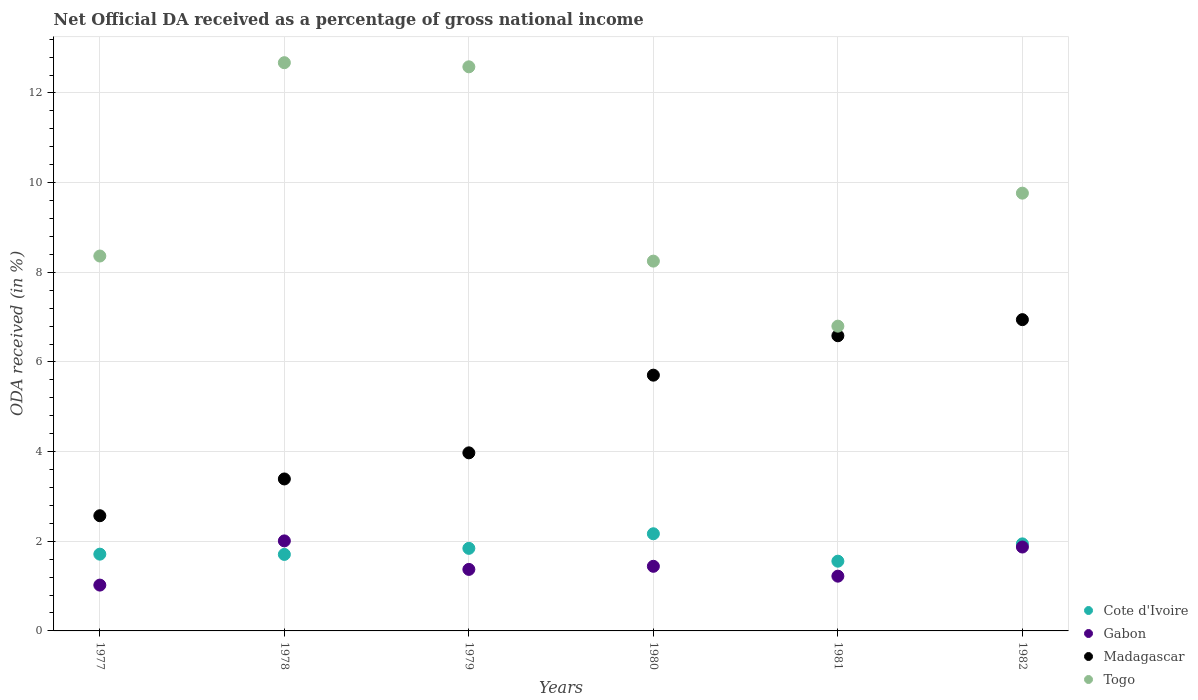What is the net official DA received in Cote d'Ivoire in 1982?
Offer a very short reply. 1.94. Across all years, what is the maximum net official DA received in Madagascar?
Offer a very short reply. 6.94. Across all years, what is the minimum net official DA received in Gabon?
Provide a short and direct response. 1.02. What is the total net official DA received in Cote d'Ivoire in the graph?
Provide a short and direct response. 10.93. What is the difference between the net official DA received in Togo in 1978 and that in 1980?
Ensure brevity in your answer.  4.43. What is the difference between the net official DA received in Togo in 1980 and the net official DA received in Madagascar in 1977?
Ensure brevity in your answer.  5.68. What is the average net official DA received in Madagascar per year?
Provide a succinct answer. 4.86. In the year 1982, what is the difference between the net official DA received in Madagascar and net official DA received in Togo?
Your response must be concise. -2.82. What is the ratio of the net official DA received in Cote d'Ivoire in 1978 to that in 1982?
Offer a very short reply. 0.88. What is the difference between the highest and the second highest net official DA received in Gabon?
Keep it short and to the point. 0.14. What is the difference between the highest and the lowest net official DA received in Togo?
Offer a very short reply. 5.88. In how many years, is the net official DA received in Gabon greater than the average net official DA received in Gabon taken over all years?
Offer a very short reply. 2. Is it the case that in every year, the sum of the net official DA received in Gabon and net official DA received in Madagascar  is greater than the sum of net official DA received in Togo and net official DA received in Cote d'Ivoire?
Offer a very short reply. No. Is it the case that in every year, the sum of the net official DA received in Cote d'Ivoire and net official DA received in Togo  is greater than the net official DA received in Gabon?
Offer a terse response. Yes. How many dotlines are there?
Give a very brief answer. 4. How many years are there in the graph?
Provide a succinct answer. 6. What is the difference between two consecutive major ticks on the Y-axis?
Your answer should be compact. 2. Are the values on the major ticks of Y-axis written in scientific E-notation?
Keep it short and to the point. No. Where does the legend appear in the graph?
Keep it short and to the point. Bottom right. How many legend labels are there?
Your answer should be compact. 4. What is the title of the graph?
Give a very brief answer. Net Official DA received as a percentage of gross national income. What is the label or title of the Y-axis?
Give a very brief answer. ODA received (in %). What is the ODA received (in %) of Cote d'Ivoire in 1977?
Your answer should be very brief. 1.71. What is the ODA received (in %) in Gabon in 1977?
Your answer should be compact. 1.02. What is the ODA received (in %) of Madagascar in 1977?
Your answer should be compact. 2.57. What is the ODA received (in %) in Togo in 1977?
Ensure brevity in your answer.  8.36. What is the ODA received (in %) in Cote d'Ivoire in 1978?
Ensure brevity in your answer.  1.71. What is the ODA received (in %) in Gabon in 1978?
Provide a succinct answer. 2.01. What is the ODA received (in %) in Madagascar in 1978?
Keep it short and to the point. 3.39. What is the ODA received (in %) of Togo in 1978?
Your response must be concise. 12.68. What is the ODA received (in %) in Cote d'Ivoire in 1979?
Offer a terse response. 1.84. What is the ODA received (in %) of Gabon in 1979?
Your answer should be compact. 1.37. What is the ODA received (in %) of Madagascar in 1979?
Provide a short and direct response. 3.97. What is the ODA received (in %) of Togo in 1979?
Keep it short and to the point. 12.58. What is the ODA received (in %) of Cote d'Ivoire in 1980?
Your answer should be very brief. 2.17. What is the ODA received (in %) of Gabon in 1980?
Provide a short and direct response. 1.44. What is the ODA received (in %) in Madagascar in 1980?
Make the answer very short. 5.71. What is the ODA received (in %) of Togo in 1980?
Your response must be concise. 8.25. What is the ODA received (in %) in Cote d'Ivoire in 1981?
Offer a terse response. 1.56. What is the ODA received (in %) in Gabon in 1981?
Offer a terse response. 1.22. What is the ODA received (in %) in Madagascar in 1981?
Provide a succinct answer. 6.58. What is the ODA received (in %) in Togo in 1981?
Your response must be concise. 6.8. What is the ODA received (in %) of Cote d'Ivoire in 1982?
Your answer should be compact. 1.94. What is the ODA received (in %) of Gabon in 1982?
Your answer should be compact. 1.87. What is the ODA received (in %) in Madagascar in 1982?
Give a very brief answer. 6.94. What is the ODA received (in %) of Togo in 1982?
Offer a very short reply. 9.76. Across all years, what is the maximum ODA received (in %) of Cote d'Ivoire?
Offer a very short reply. 2.17. Across all years, what is the maximum ODA received (in %) in Gabon?
Offer a very short reply. 2.01. Across all years, what is the maximum ODA received (in %) in Madagascar?
Ensure brevity in your answer.  6.94. Across all years, what is the maximum ODA received (in %) of Togo?
Your answer should be compact. 12.68. Across all years, what is the minimum ODA received (in %) of Cote d'Ivoire?
Offer a terse response. 1.56. Across all years, what is the minimum ODA received (in %) in Gabon?
Give a very brief answer. 1.02. Across all years, what is the minimum ODA received (in %) of Madagascar?
Your answer should be very brief. 2.57. Across all years, what is the minimum ODA received (in %) of Togo?
Ensure brevity in your answer.  6.8. What is the total ODA received (in %) in Cote d'Ivoire in the graph?
Ensure brevity in your answer.  10.93. What is the total ODA received (in %) of Gabon in the graph?
Provide a succinct answer. 8.94. What is the total ODA received (in %) of Madagascar in the graph?
Provide a succinct answer. 29.16. What is the total ODA received (in %) of Togo in the graph?
Provide a succinct answer. 58.43. What is the difference between the ODA received (in %) of Cote d'Ivoire in 1977 and that in 1978?
Make the answer very short. 0.01. What is the difference between the ODA received (in %) of Gabon in 1977 and that in 1978?
Offer a terse response. -0.99. What is the difference between the ODA received (in %) of Madagascar in 1977 and that in 1978?
Offer a terse response. -0.82. What is the difference between the ODA received (in %) in Togo in 1977 and that in 1978?
Provide a short and direct response. -4.31. What is the difference between the ODA received (in %) of Cote d'Ivoire in 1977 and that in 1979?
Ensure brevity in your answer.  -0.13. What is the difference between the ODA received (in %) of Gabon in 1977 and that in 1979?
Make the answer very short. -0.35. What is the difference between the ODA received (in %) in Madagascar in 1977 and that in 1979?
Your answer should be compact. -1.4. What is the difference between the ODA received (in %) of Togo in 1977 and that in 1979?
Provide a short and direct response. -4.22. What is the difference between the ODA received (in %) in Cote d'Ivoire in 1977 and that in 1980?
Your response must be concise. -0.46. What is the difference between the ODA received (in %) in Gabon in 1977 and that in 1980?
Give a very brief answer. -0.42. What is the difference between the ODA received (in %) in Madagascar in 1977 and that in 1980?
Give a very brief answer. -3.14. What is the difference between the ODA received (in %) in Togo in 1977 and that in 1980?
Provide a succinct answer. 0.11. What is the difference between the ODA received (in %) in Cote d'Ivoire in 1977 and that in 1981?
Make the answer very short. 0.16. What is the difference between the ODA received (in %) of Gabon in 1977 and that in 1981?
Offer a terse response. -0.2. What is the difference between the ODA received (in %) in Madagascar in 1977 and that in 1981?
Ensure brevity in your answer.  -4.01. What is the difference between the ODA received (in %) in Togo in 1977 and that in 1981?
Your answer should be very brief. 1.56. What is the difference between the ODA received (in %) in Cote d'Ivoire in 1977 and that in 1982?
Keep it short and to the point. -0.23. What is the difference between the ODA received (in %) of Gabon in 1977 and that in 1982?
Make the answer very short. -0.85. What is the difference between the ODA received (in %) of Madagascar in 1977 and that in 1982?
Make the answer very short. -4.37. What is the difference between the ODA received (in %) in Togo in 1977 and that in 1982?
Your answer should be compact. -1.4. What is the difference between the ODA received (in %) in Cote d'Ivoire in 1978 and that in 1979?
Offer a terse response. -0.14. What is the difference between the ODA received (in %) of Gabon in 1978 and that in 1979?
Ensure brevity in your answer.  0.64. What is the difference between the ODA received (in %) in Madagascar in 1978 and that in 1979?
Offer a terse response. -0.58. What is the difference between the ODA received (in %) in Togo in 1978 and that in 1979?
Offer a terse response. 0.09. What is the difference between the ODA received (in %) of Cote d'Ivoire in 1978 and that in 1980?
Your response must be concise. -0.46. What is the difference between the ODA received (in %) of Gabon in 1978 and that in 1980?
Your answer should be compact. 0.57. What is the difference between the ODA received (in %) of Madagascar in 1978 and that in 1980?
Ensure brevity in your answer.  -2.32. What is the difference between the ODA received (in %) in Togo in 1978 and that in 1980?
Make the answer very short. 4.43. What is the difference between the ODA received (in %) of Cote d'Ivoire in 1978 and that in 1981?
Provide a short and direct response. 0.15. What is the difference between the ODA received (in %) in Gabon in 1978 and that in 1981?
Your answer should be compact. 0.79. What is the difference between the ODA received (in %) in Madagascar in 1978 and that in 1981?
Your response must be concise. -3.19. What is the difference between the ODA received (in %) of Togo in 1978 and that in 1981?
Your answer should be very brief. 5.88. What is the difference between the ODA received (in %) of Cote d'Ivoire in 1978 and that in 1982?
Offer a very short reply. -0.24. What is the difference between the ODA received (in %) in Gabon in 1978 and that in 1982?
Give a very brief answer. 0.14. What is the difference between the ODA received (in %) of Madagascar in 1978 and that in 1982?
Provide a short and direct response. -3.55. What is the difference between the ODA received (in %) of Togo in 1978 and that in 1982?
Give a very brief answer. 2.91. What is the difference between the ODA received (in %) in Cote d'Ivoire in 1979 and that in 1980?
Your answer should be very brief. -0.33. What is the difference between the ODA received (in %) of Gabon in 1979 and that in 1980?
Provide a succinct answer. -0.07. What is the difference between the ODA received (in %) of Madagascar in 1979 and that in 1980?
Offer a terse response. -1.73. What is the difference between the ODA received (in %) in Togo in 1979 and that in 1980?
Provide a succinct answer. 4.33. What is the difference between the ODA received (in %) in Cote d'Ivoire in 1979 and that in 1981?
Offer a very short reply. 0.29. What is the difference between the ODA received (in %) in Gabon in 1979 and that in 1981?
Make the answer very short. 0.15. What is the difference between the ODA received (in %) in Madagascar in 1979 and that in 1981?
Your response must be concise. -2.61. What is the difference between the ODA received (in %) of Togo in 1979 and that in 1981?
Make the answer very short. 5.78. What is the difference between the ODA received (in %) in Cote d'Ivoire in 1979 and that in 1982?
Ensure brevity in your answer.  -0.1. What is the difference between the ODA received (in %) in Gabon in 1979 and that in 1982?
Keep it short and to the point. -0.5. What is the difference between the ODA received (in %) in Madagascar in 1979 and that in 1982?
Make the answer very short. -2.97. What is the difference between the ODA received (in %) in Togo in 1979 and that in 1982?
Your answer should be very brief. 2.82. What is the difference between the ODA received (in %) of Cote d'Ivoire in 1980 and that in 1981?
Offer a terse response. 0.61. What is the difference between the ODA received (in %) in Gabon in 1980 and that in 1981?
Give a very brief answer. 0.22. What is the difference between the ODA received (in %) in Madagascar in 1980 and that in 1981?
Offer a terse response. -0.88. What is the difference between the ODA received (in %) in Togo in 1980 and that in 1981?
Make the answer very short. 1.45. What is the difference between the ODA received (in %) in Cote d'Ivoire in 1980 and that in 1982?
Keep it short and to the point. 0.23. What is the difference between the ODA received (in %) in Gabon in 1980 and that in 1982?
Your answer should be compact. -0.43. What is the difference between the ODA received (in %) of Madagascar in 1980 and that in 1982?
Offer a very short reply. -1.24. What is the difference between the ODA received (in %) of Togo in 1980 and that in 1982?
Your response must be concise. -1.52. What is the difference between the ODA received (in %) in Cote d'Ivoire in 1981 and that in 1982?
Provide a short and direct response. -0.39. What is the difference between the ODA received (in %) of Gabon in 1981 and that in 1982?
Your response must be concise. -0.65. What is the difference between the ODA received (in %) of Madagascar in 1981 and that in 1982?
Provide a short and direct response. -0.36. What is the difference between the ODA received (in %) of Togo in 1981 and that in 1982?
Ensure brevity in your answer.  -2.97. What is the difference between the ODA received (in %) of Cote d'Ivoire in 1977 and the ODA received (in %) of Gabon in 1978?
Your response must be concise. -0.3. What is the difference between the ODA received (in %) of Cote d'Ivoire in 1977 and the ODA received (in %) of Madagascar in 1978?
Your answer should be very brief. -1.68. What is the difference between the ODA received (in %) in Cote d'Ivoire in 1977 and the ODA received (in %) in Togo in 1978?
Make the answer very short. -10.96. What is the difference between the ODA received (in %) in Gabon in 1977 and the ODA received (in %) in Madagascar in 1978?
Your answer should be compact. -2.37. What is the difference between the ODA received (in %) of Gabon in 1977 and the ODA received (in %) of Togo in 1978?
Your response must be concise. -11.65. What is the difference between the ODA received (in %) in Madagascar in 1977 and the ODA received (in %) in Togo in 1978?
Give a very brief answer. -10.11. What is the difference between the ODA received (in %) in Cote d'Ivoire in 1977 and the ODA received (in %) in Gabon in 1979?
Keep it short and to the point. 0.34. What is the difference between the ODA received (in %) in Cote d'Ivoire in 1977 and the ODA received (in %) in Madagascar in 1979?
Your answer should be very brief. -2.26. What is the difference between the ODA received (in %) in Cote d'Ivoire in 1977 and the ODA received (in %) in Togo in 1979?
Provide a succinct answer. -10.87. What is the difference between the ODA received (in %) of Gabon in 1977 and the ODA received (in %) of Madagascar in 1979?
Offer a terse response. -2.95. What is the difference between the ODA received (in %) of Gabon in 1977 and the ODA received (in %) of Togo in 1979?
Offer a terse response. -11.56. What is the difference between the ODA received (in %) in Madagascar in 1977 and the ODA received (in %) in Togo in 1979?
Your answer should be compact. -10.01. What is the difference between the ODA received (in %) of Cote d'Ivoire in 1977 and the ODA received (in %) of Gabon in 1980?
Offer a very short reply. 0.27. What is the difference between the ODA received (in %) in Cote d'Ivoire in 1977 and the ODA received (in %) in Madagascar in 1980?
Provide a short and direct response. -3.99. What is the difference between the ODA received (in %) in Cote d'Ivoire in 1977 and the ODA received (in %) in Togo in 1980?
Provide a succinct answer. -6.54. What is the difference between the ODA received (in %) of Gabon in 1977 and the ODA received (in %) of Madagascar in 1980?
Keep it short and to the point. -4.68. What is the difference between the ODA received (in %) in Gabon in 1977 and the ODA received (in %) in Togo in 1980?
Give a very brief answer. -7.23. What is the difference between the ODA received (in %) in Madagascar in 1977 and the ODA received (in %) in Togo in 1980?
Offer a very short reply. -5.68. What is the difference between the ODA received (in %) of Cote d'Ivoire in 1977 and the ODA received (in %) of Gabon in 1981?
Your response must be concise. 0.49. What is the difference between the ODA received (in %) of Cote d'Ivoire in 1977 and the ODA received (in %) of Madagascar in 1981?
Offer a terse response. -4.87. What is the difference between the ODA received (in %) in Cote d'Ivoire in 1977 and the ODA received (in %) in Togo in 1981?
Offer a terse response. -5.09. What is the difference between the ODA received (in %) of Gabon in 1977 and the ODA received (in %) of Madagascar in 1981?
Make the answer very short. -5.56. What is the difference between the ODA received (in %) in Gabon in 1977 and the ODA received (in %) in Togo in 1981?
Your response must be concise. -5.78. What is the difference between the ODA received (in %) of Madagascar in 1977 and the ODA received (in %) of Togo in 1981?
Offer a terse response. -4.23. What is the difference between the ODA received (in %) in Cote d'Ivoire in 1977 and the ODA received (in %) in Gabon in 1982?
Provide a short and direct response. -0.16. What is the difference between the ODA received (in %) in Cote d'Ivoire in 1977 and the ODA received (in %) in Madagascar in 1982?
Offer a very short reply. -5.23. What is the difference between the ODA received (in %) of Cote d'Ivoire in 1977 and the ODA received (in %) of Togo in 1982?
Provide a short and direct response. -8.05. What is the difference between the ODA received (in %) in Gabon in 1977 and the ODA received (in %) in Madagascar in 1982?
Give a very brief answer. -5.92. What is the difference between the ODA received (in %) in Gabon in 1977 and the ODA received (in %) in Togo in 1982?
Give a very brief answer. -8.74. What is the difference between the ODA received (in %) in Madagascar in 1977 and the ODA received (in %) in Togo in 1982?
Your answer should be compact. -7.2. What is the difference between the ODA received (in %) in Cote d'Ivoire in 1978 and the ODA received (in %) in Gabon in 1979?
Keep it short and to the point. 0.33. What is the difference between the ODA received (in %) in Cote d'Ivoire in 1978 and the ODA received (in %) in Madagascar in 1979?
Your response must be concise. -2.27. What is the difference between the ODA received (in %) of Cote d'Ivoire in 1978 and the ODA received (in %) of Togo in 1979?
Provide a succinct answer. -10.88. What is the difference between the ODA received (in %) of Gabon in 1978 and the ODA received (in %) of Madagascar in 1979?
Your answer should be very brief. -1.96. What is the difference between the ODA received (in %) of Gabon in 1978 and the ODA received (in %) of Togo in 1979?
Keep it short and to the point. -10.57. What is the difference between the ODA received (in %) of Madagascar in 1978 and the ODA received (in %) of Togo in 1979?
Give a very brief answer. -9.19. What is the difference between the ODA received (in %) of Cote d'Ivoire in 1978 and the ODA received (in %) of Gabon in 1980?
Keep it short and to the point. 0.27. What is the difference between the ODA received (in %) in Cote d'Ivoire in 1978 and the ODA received (in %) in Madagascar in 1980?
Offer a very short reply. -4. What is the difference between the ODA received (in %) of Cote d'Ivoire in 1978 and the ODA received (in %) of Togo in 1980?
Give a very brief answer. -6.54. What is the difference between the ODA received (in %) of Gabon in 1978 and the ODA received (in %) of Madagascar in 1980?
Provide a short and direct response. -3.7. What is the difference between the ODA received (in %) in Gabon in 1978 and the ODA received (in %) in Togo in 1980?
Ensure brevity in your answer.  -6.24. What is the difference between the ODA received (in %) of Madagascar in 1978 and the ODA received (in %) of Togo in 1980?
Your answer should be compact. -4.86. What is the difference between the ODA received (in %) of Cote d'Ivoire in 1978 and the ODA received (in %) of Gabon in 1981?
Provide a short and direct response. 0.48. What is the difference between the ODA received (in %) in Cote d'Ivoire in 1978 and the ODA received (in %) in Madagascar in 1981?
Your answer should be very brief. -4.88. What is the difference between the ODA received (in %) in Cote d'Ivoire in 1978 and the ODA received (in %) in Togo in 1981?
Offer a very short reply. -5.09. What is the difference between the ODA received (in %) of Gabon in 1978 and the ODA received (in %) of Madagascar in 1981?
Provide a succinct answer. -4.58. What is the difference between the ODA received (in %) of Gabon in 1978 and the ODA received (in %) of Togo in 1981?
Your answer should be compact. -4.79. What is the difference between the ODA received (in %) in Madagascar in 1978 and the ODA received (in %) in Togo in 1981?
Your answer should be compact. -3.41. What is the difference between the ODA received (in %) in Cote d'Ivoire in 1978 and the ODA received (in %) in Gabon in 1982?
Your answer should be very brief. -0.17. What is the difference between the ODA received (in %) of Cote d'Ivoire in 1978 and the ODA received (in %) of Madagascar in 1982?
Provide a succinct answer. -5.24. What is the difference between the ODA received (in %) in Cote d'Ivoire in 1978 and the ODA received (in %) in Togo in 1982?
Your answer should be compact. -8.06. What is the difference between the ODA received (in %) of Gabon in 1978 and the ODA received (in %) of Madagascar in 1982?
Provide a succinct answer. -4.93. What is the difference between the ODA received (in %) in Gabon in 1978 and the ODA received (in %) in Togo in 1982?
Provide a short and direct response. -7.76. What is the difference between the ODA received (in %) in Madagascar in 1978 and the ODA received (in %) in Togo in 1982?
Offer a terse response. -6.38. What is the difference between the ODA received (in %) in Cote d'Ivoire in 1979 and the ODA received (in %) in Gabon in 1980?
Offer a terse response. 0.4. What is the difference between the ODA received (in %) of Cote d'Ivoire in 1979 and the ODA received (in %) of Madagascar in 1980?
Make the answer very short. -3.86. What is the difference between the ODA received (in %) of Cote d'Ivoire in 1979 and the ODA received (in %) of Togo in 1980?
Keep it short and to the point. -6.41. What is the difference between the ODA received (in %) of Gabon in 1979 and the ODA received (in %) of Madagascar in 1980?
Your answer should be very brief. -4.33. What is the difference between the ODA received (in %) of Gabon in 1979 and the ODA received (in %) of Togo in 1980?
Keep it short and to the point. -6.88. What is the difference between the ODA received (in %) of Madagascar in 1979 and the ODA received (in %) of Togo in 1980?
Your response must be concise. -4.28. What is the difference between the ODA received (in %) of Cote d'Ivoire in 1979 and the ODA received (in %) of Gabon in 1981?
Your answer should be very brief. 0.62. What is the difference between the ODA received (in %) of Cote d'Ivoire in 1979 and the ODA received (in %) of Madagascar in 1981?
Your response must be concise. -4.74. What is the difference between the ODA received (in %) of Cote d'Ivoire in 1979 and the ODA received (in %) of Togo in 1981?
Offer a terse response. -4.96. What is the difference between the ODA received (in %) in Gabon in 1979 and the ODA received (in %) in Madagascar in 1981?
Keep it short and to the point. -5.21. What is the difference between the ODA received (in %) of Gabon in 1979 and the ODA received (in %) of Togo in 1981?
Offer a terse response. -5.43. What is the difference between the ODA received (in %) in Madagascar in 1979 and the ODA received (in %) in Togo in 1981?
Keep it short and to the point. -2.83. What is the difference between the ODA received (in %) in Cote d'Ivoire in 1979 and the ODA received (in %) in Gabon in 1982?
Offer a terse response. -0.03. What is the difference between the ODA received (in %) of Cote d'Ivoire in 1979 and the ODA received (in %) of Madagascar in 1982?
Your answer should be very brief. -5.1. What is the difference between the ODA received (in %) of Cote d'Ivoire in 1979 and the ODA received (in %) of Togo in 1982?
Provide a short and direct response. -7.92. What is the difference between the ODA received (in %) in Gabon in 1979 and the ODA received (in %) in Madagascar in 1982?
Keep it short and to the point. -5.57. What is the difference between the ODA received (in %) of Gabon in 1979 and the ODA received (in %) of Togo in 1982?
Ensure brevity in your answer.  -8.39. What is the difference between the ODA received (in %) in Madagascar in 1979 and the ODA received (in %) in Togo in 1982?
Your answer should be compact. -5.79. What is the difference between the ODA received (in %) in Cote d'Ivoire in 1980 and the ODA received (in %) in Gabon in 1981?
Keep it short and to the point. 0.95. What is the difference between the ODA received (in %) in Cote d'Ivoire in 1980 and the ODA received (in %) in Madagascar in 1981?
Give a very brief answer. -4.42. What is the difference between the ODA received (in %) in Cote d'Ivoire in 1980 and the ODA received (in %) in Togo in 1981?
Make the answer very short. -4.63. What is the difference between the ODA received (in %) of Gabon in 1980 and the ODA received (in %) of Madagascar in 1981?
Keep it short and to the point. -5.14. What is the difference between the ODA received (in %) of Gabon in 1980 and the ODA received (in %) of Togo in 1981?
Your answer should be very brief. -5.36. What is the difference between the ODA received (in %) of Madagascar in 1980 and the ODA received (in %) of Togo in 1981?
Your answer should be compact. -1.09. What is the difference between the ODA received (in %) of Cote d'Ivoire in 1980 and the ODA received (in %) of Gabon in 1982?
Ensure brevity in your answer.  0.3. What is the difference between the ODA received (in %) in Cote d'Ivoire in 1980 and the ODA received (in %) in Madagascar in 1982?
Offer a very short reply. -4.78. What is the difference between the ODA received (in %) in Cote d'Ivoire in 1980 and the ODA received (in %) in Togo in 1982?
Make the answer very short. -7.6. What is the difference between the ODA received (in %) in Gabon in 1980 and the ODA received (in %) in Madagascar in 1982?
Give a very brief answer. -5.5. What is the difference between the ODA received (in %) of Gabon in 1980 and the ODA received (in %) of Togo in 1982?
Offer a terse response. -8.32. What is the difference between the ODA received (in %) in Madagascar in 1980 and the ODA received (in %) in Togo in 1982?
Ensure brevity in your answer.  -4.06. What is the difference between the ODA received (in %) of Cote d'Ivoire in 1981 and the ODA received (in %) of Gabon in 1982?
Your answer should be compact. -0.32. What is the difference between the ODA received (in %) of Cote d'Ivoire in 1981 and the ODA received (in %) of Madagascar in 1982?
Provide a short and direct response. -5.39. What is the difference between the ODA received (in %) in Cote d'Ivoire in 1981 and the ODA received (in %) in Togo in 1982?
Provide a short and direct response. -8.21. What is the difference between the ODA received (in %) in Gabon in 1981 and the ODA received (in %) in Madagascar in 1982?
Your answer should be compact. -5.72. What is the difference between the ODA received (in %) of Gabon in 1981 and the ODA received (in %) of Togo in 1982?
Provide a succinct answer. -8.54. What is the difference between the ODA received (in %) in Madagascar in 1981 and the ODA received (in %) in Togo in 1982?
Ensure brevity in your answer.  -3.18. What is the average ODA received (in %) in Cote d'Ivoire per year?
Make the answer very short. 1.82. What is the average ODA received (in %) of Gabon per year?
Your response must be concise. 1.49. What is the average ODA received (in %) of Madagascar per year?
Give a very brief answer. 4.86. What is the average ODA received (in %) of Togo per year?
Your response must be concise. 9.74. In the year 1977, what is the difference between the ODA received (in %) in Cote d'Ivoire and ODA received (in %) in Gabon?
Give a very brief answer. 0.69. In the year 1977, what is the difference between the ODA received (in %) of Cote d'Ivoire and ODA received (in %) of Madagascar?
Your answer should be very brief. -0.86. In the year 1977, what is the difference between the ODA received (in %) of Cote d'Ivoire and ODA received (in %) of Togo?
Give a very brief answer. -6.65. In the year 1977, what is the difference between the ODA received (in %) of Gabon and ODA received (in %) of Madagascar?
Your answer should be very brief. -1.55. In the year 1977, what is the difference between the ODA received (in %) in Gabon and ODA received (in %) in Togo?
Offer a terse response. -7.34. In the year 1977, what is the difference between the ODA received (in %) in Madagascar and ODA received (in %) in Togo?
Make the answer very short. -5.79. In the year 1978, what is the difference between the ODA received (in %) in Cote d'Ivoire and ODA received (in %) in Gabon?
Make the answer very short. -0.3. In the year 1978, what is the difference between the ODA received (in %) of Cote d'Ivoire and ODA received (in %) of Madagascar?
Offer a very short reply. -1.68. In the year 1978, what is the difference between the ODA received (in %) of Cote d'Ivoire and ODA received (in %) of Togo?
Provide a short and direct response. -10.97. In the year 1978, what is the difference between the ODA received (in %) of Gabon and ODA received (in %) of Madagascar?
Your response must be concise. -1.38. In the year 1978, what is the difference between the ODA received (in %) of Gabon and ODA received (in %) of Togo?
Make the answer very short. -10.67. In the year 1978, what is the difference between the ODA received (in %) of Madagascar and ODA received (in %) of Togo?
Your answer should be very brief. -9.29. In the year 1979, what is the difference between the ODA received (in %) in Cote d'Ivoire and ODA received (in %) in Gabon?
Give a very brief answer. 0.47. In the year 1979, what is the difference between the ODA received (in %) in Cote d'Ivoire and ODA received (in %) in Madagascar?
Provide a succinct answer. -2.13. In the year 1979, what is the difference between the ODA received (in %) of Cote d'Ivoire and ODA received (in %) of Togo?
Your answer should be very brief. -10.74. In the year 1979, what is the difference between the ODA received (in %) of Gabon and ODA received (in %) of Madagascar?
Ensure brevity in your answer.  -2.6. In the year 1979, what is the difference between the ODA received (in %) in Gabon and ODA received (in %) in Togo?
Keep it short and to the point. -11.21. In the year 1979, what is the difference between the ODA received (in %) in Madagascar and ODA received (in %) in Togo?
Ensure brevity in your answer.  -8.61. In the year 1980, what is the difference between the ODA received (in %) in Cote d'Ivoire and ODA received (in %) in Gabon?
Provide a succinct answer. 0.73. In the year 1980, what is the difference between the ODA received (in %) in Cote d'Ivoire and ODA received (in %) in Madagascar?
Give a very brief answer. -3.54. In the year 1980, what is the difference between the ODA received (in %) in Cote d'Ivoire and ODA received (in %) in Togo?
Offer a very short reply. -6.08. In the year 1980, what is the difference between the ODA received (in %) of Gabon and ODA received (in %) of Madagascar?
Offer a very short reply. -4.26. In the year 1980, what is the difference between the ODA received (in %) in Gabon and ODA received (in %) in Togo?
Provide a succinct answer. -6.81. In the year 1980, what is the difference between the ODA received (in %) in Madagascar and ODA received (in %) in Togo?
Make the answer very short. -2.54. In the year 1981, what is the difference between the ODA received (in %) of Cote d'Ivoire and ODA received (in %) of Gabon?
Keep it short and to the point. 0.33. In the year 1981, what is the difference between the ODA received (in %) in Cote d'Ivoire and ODA received (in %) in Madagascar?
Ensure brevity in your answer.  -5.03. In the year 1981, what is the difference between the ODA received (in %) of Cote d'Ivoire and ODA received (in %) of Togo?
Make the answer very short. -5.24. In the year 1981, what is the difference between the ODA received (in %) of Gabon and ODA received (in %) of Madagascar?
Make the answer very short. -5.36. In the year 1981, what is the difference between the ODA received (in %) of Gabon and ODA received (in %) of Togo?
Provide a short and direct response. -5.58. In the year 1981, what is the difference between the ODA received (in %) of Madagascar and ODA received (in %) of Togo?
Ensure brevity in your answer.  -0.21. In the year 1982, what is the difference between the ODA received (in %) of Cote d'Ivoire and ODA received (in %) of Gabon?
Make the answer very short. 0.07. In the year 1982, what is the difference between the ODA received (in %) in Cote d'Ivoire and ODA received (in %) in Madagascar?
Ensure brevity in your answer.  -5. In the year 1982, what is the difference between the ODA received (in %) of Cote d'Ivoire and ODA received (in %) of Togo?
Your answer should be very brief. -7.82. In the year 1982, what is the difference between the ODA received (in %) in Gabon and ODA received (in %) in Madagascar?
Keep it short and to the point. -5.07. In the year 1982, what is the difference between the ODA received (in %) in Gabon and ODA received (in %) in Togo?
Provide a succinct answer. -7.89. In the year 1982, what is the difference between the ODA received (in %) of Madagascar and ODA received (in %) of Togo?
Your answer should be very brief. -2.82. What is the ratio of the ODA received (in %) of Gabon in 1977 to that in 1978?
Keep it short and to the point. 0.51. What is the ratio of the ODA received (in %) in Madagascar in 1977 to that in 1978?
Keep it short and to the point. 0.76. What is the ratio of the ODA received (in %) of Togo in 1977 to that in 1978?
Provide a short and direct response. 0.66. What is the ratio of the ODA received (in %) in Cote d'Ivoire in 1977 to that in 1979?
Provide a succinct answer. 0.93. What is the ratio of the ODA received (in %) in Gabon in 1977 to that in 1979?
Provide a short and direct response. 0.74. What is the ratio of the ODA received (in %) of Madagascar in 1977 to that in 1979?
Your response must be concise. 0.65. What is the ratio of the ODA received (in %) in Togo in 1977 to that in 1979?
Ensure brevity in your answer.  0.66. What is the ratio of the ODA received (in %) of Cote d'Ivoire in 1977 to that in 1980?
Your answer should be very brief. 0.79. What is the ratio of the ODA received (in %) of Gabon in 1977 to that in 1980?
Your answer should be very brief. 0.71. What is the ratio of the ODA received (in %) of Madagascar in 1977 to that in 1980?
Ensure brevity in your answer.  0.45. What is the ratio of the ODA received (in %) in Togo in 1977 to that in 1980?
Offer a terse response. 1.01. What is the ratio of the ODA received (in %) in Cote d'Ivoire in 1977 to that in 1981?
Provide a short and direct response. 1.1. What is the ratio of the ODA received (in %) of Gabon in 1977 to that in 1981?
Ensure brevity in your answer.  0.84. What is the ratio of the ODA received (in %) of Madagascar in 1977 to that in 1981?
Your response must be concise. 0.39. What is the ratio of the ODA received (in %) in Togo in 1977 to that in 1981?
Keep it short and to the point. 1.23. What is the ratio of the ODA received (in %) in Cote d'Ivoire in 1977 to that in 1982?
Make the answer very short. 0.88. What is the ratio of the ODA received (in %) of Gabon in 1977 to that in 1982?
Provide a short and direct response. 0.55. What is the ratio of the ODA received (in %) of Madagascar in 1977 to that in 1982?
Give a very brief answer. 0.37. What is the ratio of the ODA received (in %) of Togo in 1977 to that in 1982?
Provide a short and direct response. 0.86. What is the ratio of the ODA received (in %) of Cote d'Ivoire in 1978 to that in 1979?
Make the answer very short. 0.93. What is the ratio of the ODA received (in %) of Gabon in 1978 to that in 1979?
Make the answer very short. 1.46. What is the ratio of the ODA received (in %) in Madagascar in 1978 to that in 1979?
Provide a succinct answer. 0.85. What is the ratio of the ODA received (in %) in Togo in 1978 to that in 1979?
Provide a short and direct response. 1.01. What is the ratio of the ODA received (in %) of Cote d'Ivoire in 1978 to that in 1980?
Make the answer very short. 0.79. What is the ratio of the ODA received (in %) in Gabon in 1978 to that in 1980?
Your response must be concise. 1.39. What is the ratio of the ODA received (in %) of Madagascar in 1978 to that in 1980?
Give a very brief answer. 0.59. What is the ratio of the ODA received (in %) of Togo in 1978 to that in 1980?
Provide a short and direct response. 1.54. What is the ratio of the ODA received (in %) in Cote d'Ivoire in 1978 to that in 1981?
Provide a short and direct response. 1.1. What is the ratio of the ODA received (in %) in Gabon in 1978 to that in 1981?
Give a very brief answer. 1.64. What is the ratio of the ODA received (in %) of Madagascar in 1978 to that in 1981?
Ensure brevity in your answer.  0.51. What is the ratio of the ODA received (in %) in Togo in 1978 to that in 1981?
Provide a succinct answer. 1.86. What is the ratio of the ODA received (in %) in Cote d'Ivoire in 1978 to that in 1982?
Make the answer very short. 0.88. What is the ratio of the ODA received (in %) of Gabon in 1978 to that in 1982?
Offer a very short reply. 1.07. What is the ratio of the ODA received (in %) of Madagascar in 1978 to that in 1982?
Provide a short and direct response. 0.49. What is the ratio of the ODA received (in %) in Togo in 1978 to that in 1982?
Your answer should be very brief. 1.3. What is the ratio of the ODA received (in %) in Cote d'Ivoire in 1979 to that in 1980?
Ensure brevity in your answer.  0.85. What is the ratio of the ODA received (in %) in Gabon in 1979 to that in 1980?
Your answer should be very brief. 0.95. What is the ratio of the ODA received (in %) of Madagascar in 1979 to that in 1980?
Give a very brief answer. 0.7. What is the ratio of the ODA received (in %) in Togo in 1979 to that in 1980?
Your answer should be very brief. 1.53. What is the ratio of the ODA received (in %) in Cote d'Ivoire in 1979 to that in 1981?
Give a very brief answer. 1.18. What is the ratio of the ODA received (in %) of Gabon in 1979 to that in 1981?
Keep it short and to the point. 1.12. What is the ratio of the ODA received (in %) in Madagascar in 1979 to that in 1981?
Provide a short and direct response. 0.6. What is the ratio of the ODA received (in %) of Togo in 1979 to that in 1981?
Keep it short and to the point. 1.85. What is the ratio of the ODA received (in %) of Cote d'Ivoire in 1979 to that in 1982?
Your answer should be compact. 0.95. What is the ratio of the ODA received (in %) in Gabon in 1979 to that in 1982?
Provide a succinct answer. 0.73. What is the ratio of the ODA received (in %) of Madagascar in 1979 to that in 1982?
Offer a very short reply. 0.57. What is the ratio of the ODA received (in %) of Togo in 1979 to that in 1982?
Ensure brevity in your answer.  1.29. What is the ratio of the ODA received (in %) of Cote d'Ivoire in 1980 to that in 1981?
Ensure brevity in your answer.  1.39. What is the ratio of the ODA received (in %) of Gabon in 1980 to that in 1981?
Give a very brief answer. 1.18. What is the ratio of the ODA received (in %) of Madagascar in 1980 to that in 1981?
Your response must be concise. 0.87. What is the ratio of the ODA received (in %) of Togo in 1980 to that in 1981?
Provide a short and direct response. 1.21. What is the ratio of the ODA received (in %) of Cote d'Ivoire in 1980 to that in 1982?
Offer a terse response. 1.12. What is the ratio of the ODA received (in %) of Gabon in 1980 to that in 1982?
Provide a short and direct response. 0.77. What is the ratio of the ODA received (in %) in Madagascar in 1980 to that in 1982?
Your answer should be compact. 0.82. What is the ratio of the ODA received (in %) of Togo in 1980 to that in 1982?
Ensure brevity in your answer.  0.84. What is the ratio of the ODA received (in %) in Cote d'Ivoire in 1981 to that in 1982?
Keep it short and to the point. 0.8. What is the ratio of the ODA received (in %) of Gabon in 1981 to that in 1982?
Provide a succinct answer. 0.65. What is the ratio of the ODA received (in %) in Madagascar in 1981 to that in 1982?
Ensure brevity in your answer.  0.95. What is the ratio of the ODA received (in %) in Togo in 1981 to that in 1982?
Keep it short and to the point. 0.7. What is the difference between the highest and the second highest ODA received (in %) of Cote d'Ivoire?
Make the answer very short. 0.23. What is the difference between the highest and the second highest ODA received (in %) in Gabon?
Offer a terse response. 0.14. What is the difference between the highest and the second highest ODA received (in %) of Madagascar?
Offer a very short reply. 0.36. What is the difference between the highest and the second highest ODA received (in %) of Togo?
Ensure brevity in your answer.  0.09. What is the difference between the highest and the lowest ODA received (in %) of Cote d'Ivoire?
Your answer should be very brief. 0.61. What is the difference between the highest and the lowest ODA received (in %) in Madagascar?
Offer a very short reply. 4.37. What is the difference between the highest and the lowest ODA received (in %) in Togo?
Offer a very short reply. 5.88. 